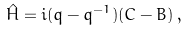Convert formula to latex. <formula><loc_0><loc_0><loc_500><loc_500>\hat { H } = i ( q - q ^ { - 1 } ) ( C - B ) \, ,</formula> 